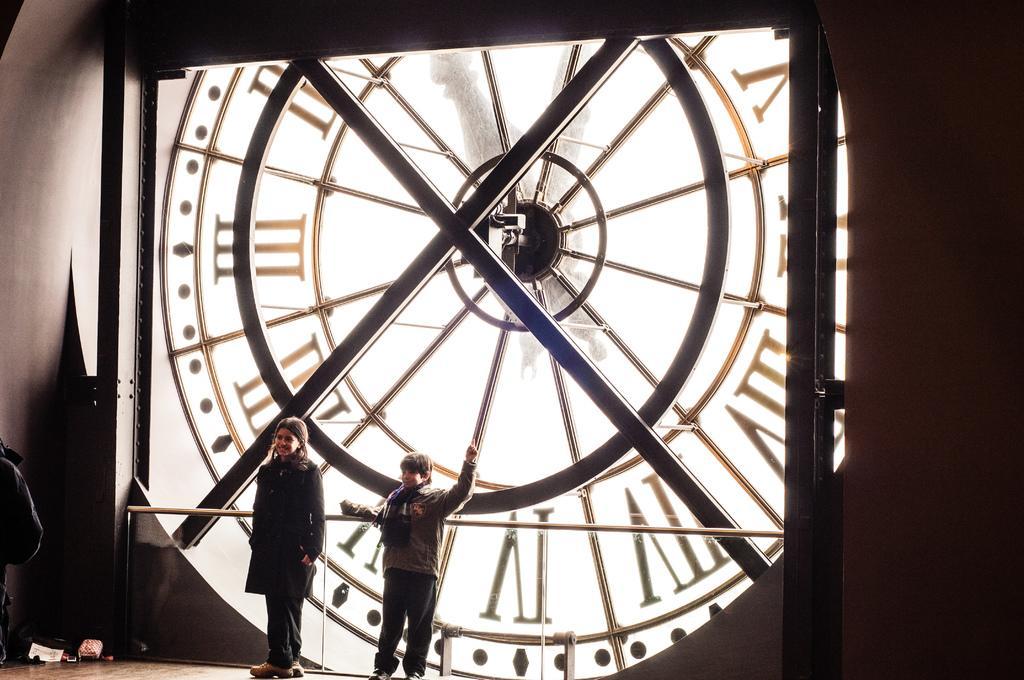Can you describe this image briefly? In the image there are two kids standing in front of a huge clock. 